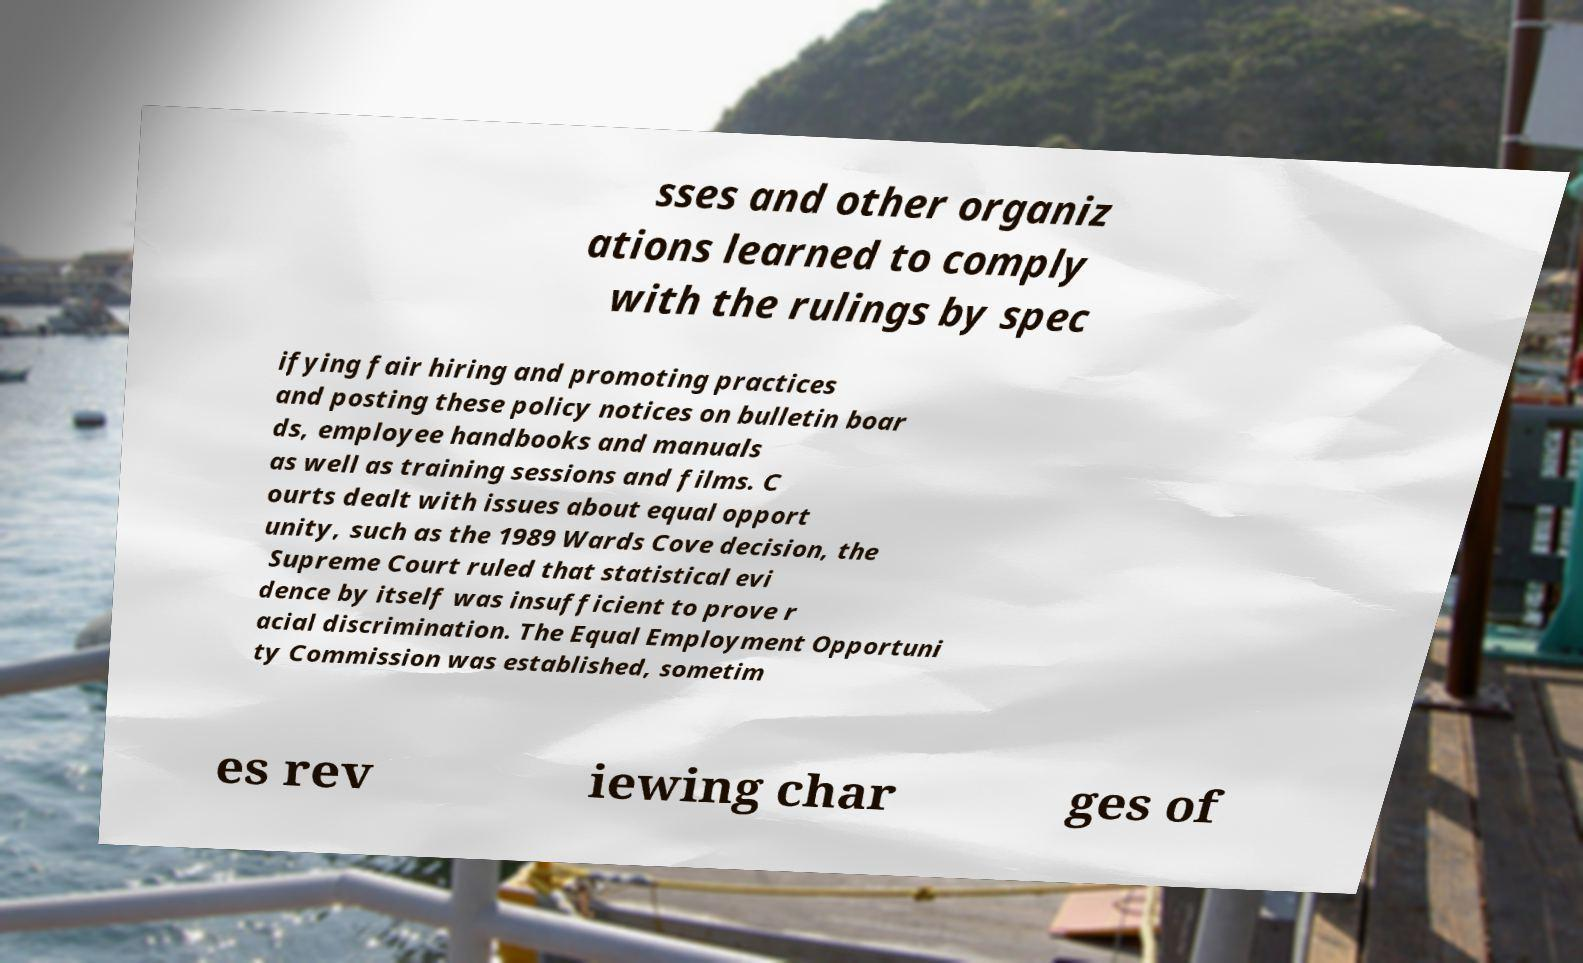I need the written content from this picture converted into text. Can you do that? sses and other organiz ations learned to comply with the rulings by spec ifying fair hiring and promoting practices and posting these policy notices on bulletin boar ds, employee handbooks and manuals as well as training sessions and films. C ourts dealt with issues about equal opport unity, such as the 1989 Wards Cove decision, the Supreme Court ruled that statistical evi dence by itself was insufficient to prove r acial discrimination. The Equal Employment Opportuni ty Commission was established, sometim es rev iewing char ges of 